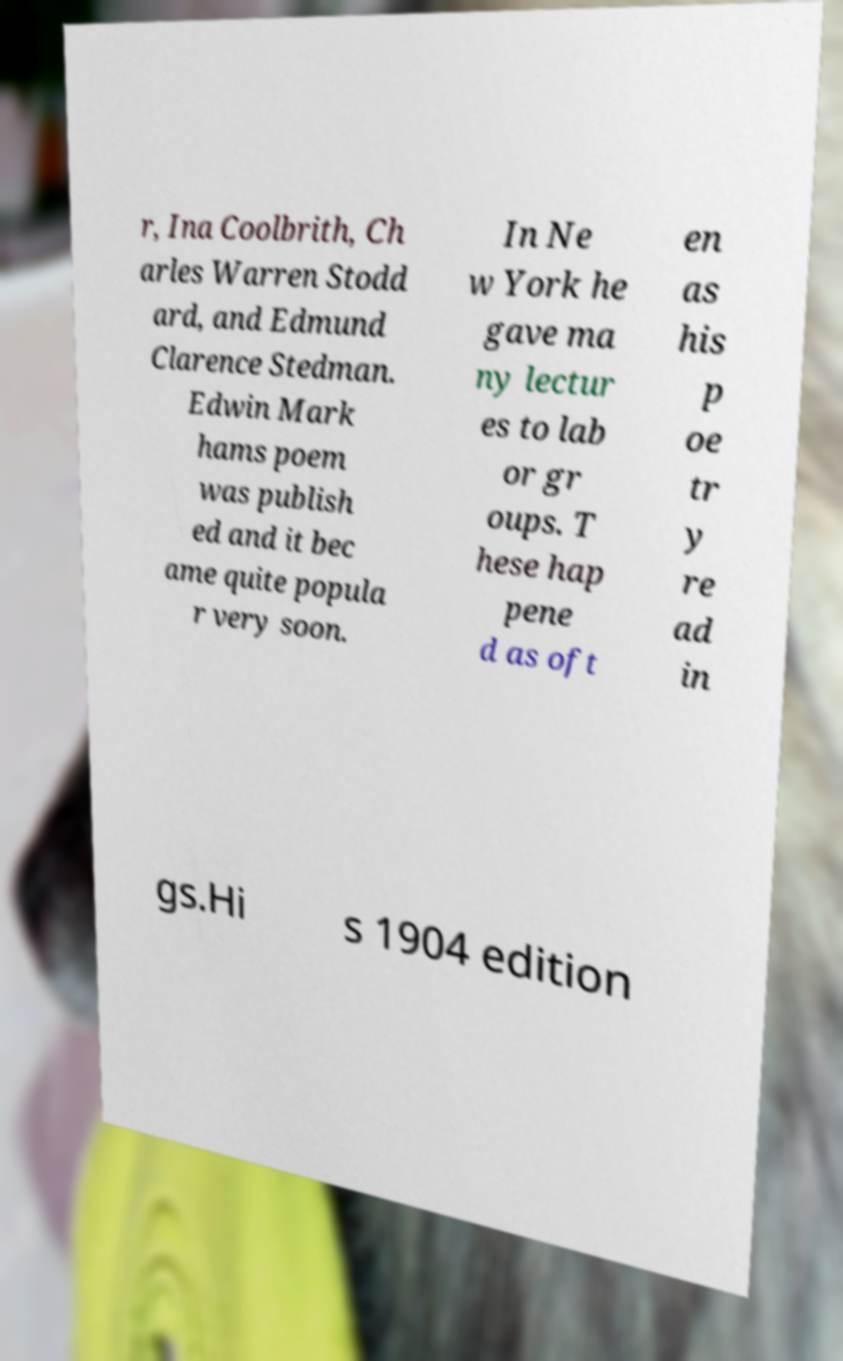Please read and relay the text visible in this image. What does it say? r, Ina Coolbrith, Ch arles Warren Stodd ard, and Edmund Clarence Stedman. Edwin Mark hams poem was publish ed and it bec ame quite popula r very soon. In Ne w York he gave ma ny lectur es to lab or gr oups. T hese hap pene d as oft en as his p oe tr y re ad in gs.Hi s 1904 edition 